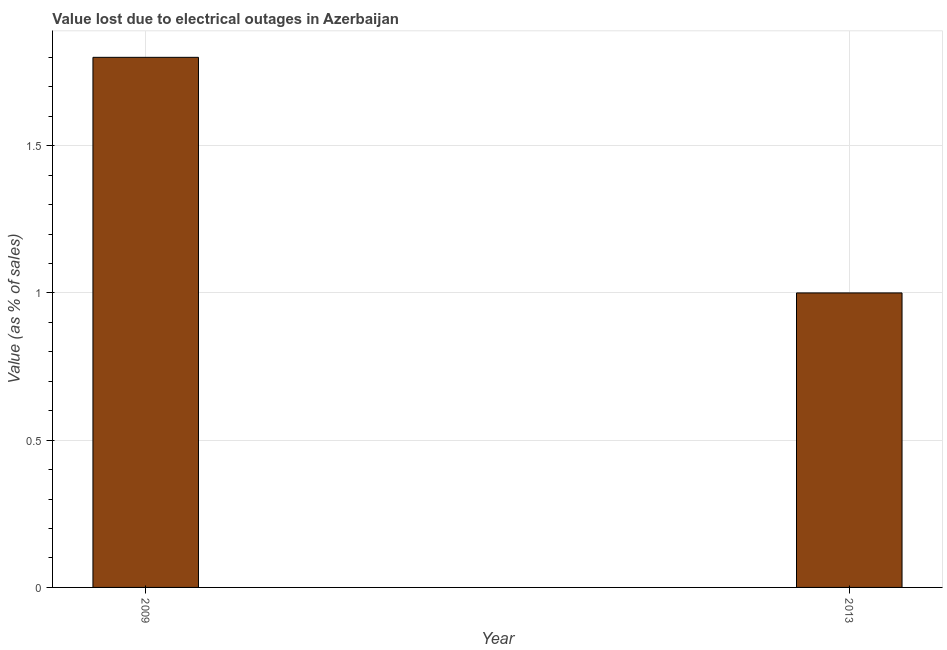Does the graph contain any zero values?
Offer a very short reply. No. What is the title of the graph?
Your answer should be compact. Value lost due to electrical outages in Azerbaijan. What is the label or title of the X-axis?
Offer a terse response. Year. What is the label or title of the Y-axis?
Ensure brevity in your answer.  Value (as % of sales). Across all years, what is the minimum value lost due to electrical outages?
Offer a terse response. 1. In which year was the value lost due to electrical outages maximum?
Provide a succinct answer. 2009. In which year was the value lost due to electrical outages minimum?
Ensure brevity in your answer.  2013. What is the sum of the value lost due to electrical outages?
Ensure brevity in your answer.  2.8. In how many years, is the value lost due to electrical outages greater than 1.3 %?
Your answer should be compact. 1. Do a majority of the years between 2009 and 2013 (inclusive) have value lost due to electrical outages greater than 1.2 %?
Your answer should be compact. No. Is the value lost due to electrical outages in 2009 less than that in 2013?
Give a very brief answer. No. Are all the bars in the graph horizontal?
Offer a terse response. No. What is the difference between two consecutive major ticks on the Y-axis?
Give a very brief answer. 0.5. What is the Value (as % of sales) of 2009?
Your answer should be compact. 1.8. 